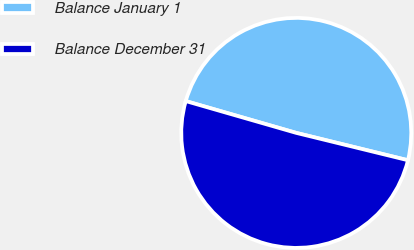Convert chart. <chart><loc_0><loc_0><loc_500><loc_500><pie_chart><fcel>Balance January 1<fcel>Balance December 31<nl><fcel>49.36%<fcel>50.64%<nl></chart> 